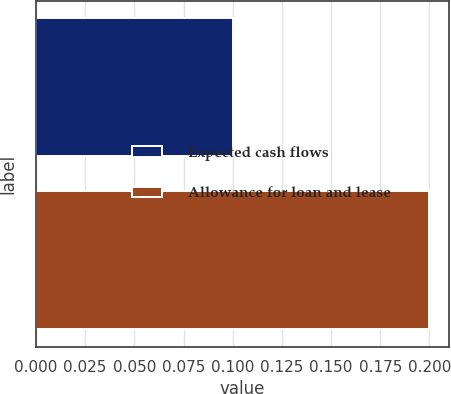Convert chart. <chart><loc_0><loc_0><loc_500><loc_500><bar_chart><fcel>Expected cash flows<fcel>Allowance for loan and lease<nl><fcel>0.1<fcel>0.2<nl></chart> 